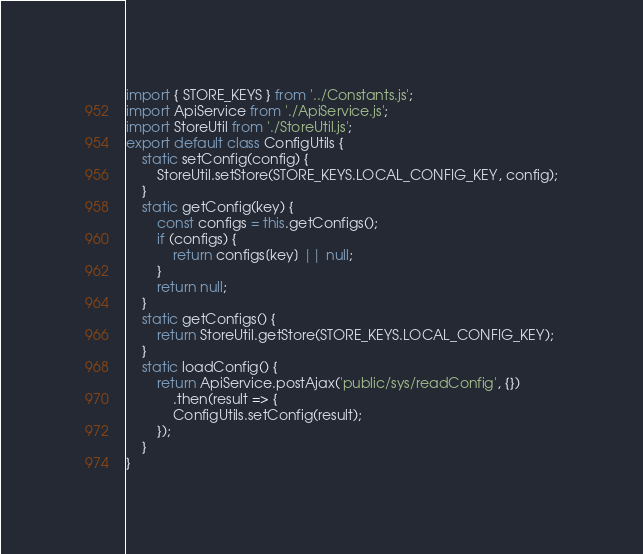Convert code to text. <code><loc_0><loc_0><loc_500><loc_500><_JavaScript_>import { STORE_KEYS } from '../Constants.js';
import ApiService from './ApiService.js';
import StoreUtil from './StoreUtil.js';
export default class ConfigUtils {
    static setConfig(config) {
        StoreUtil.setStore(STORE_KEYS.LOCAL_CONFIG_KEY, config);
    }
    static getConfig(key) {
        const configs = this.getConfigs();
        if (configs) {
            return configs[key] || null;
        }
        return null;
    }
    static getConfigs() {
        return StoreUtil.getStore(STORE_KEYS.LOCAL_CONFIG_KEY);
    }
    static loadConfig() {
        return ApiService.postAjax('public/sys/readConfig', {})
            .then(result => {
            ConfigUtils.setConfig(result);
        });
    }
}
</code> 